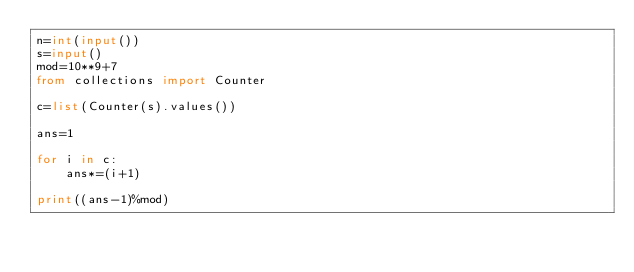Convert code to text. <code><loc_0><loc_0><loc_500><loc_500><_Python_>n=int(input())
s=input()
mod=10**9+7
from collections import Counter

c=list(Counter(s).values())

ans=1

for i in c:
    ans*=(i+1)

print((ans-1)%mod)
</code> 